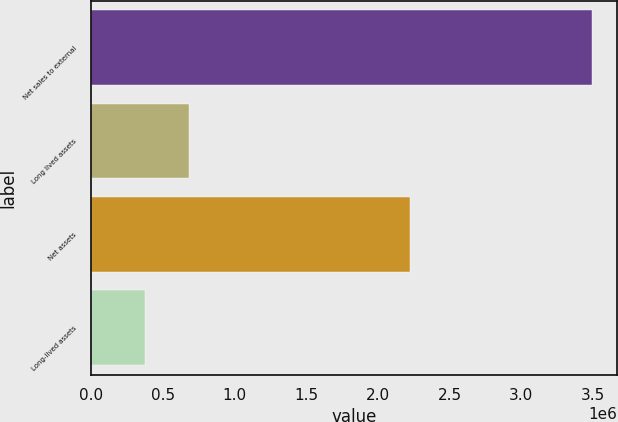Convert chart to OTSL. <chart><loc_0><loc_0><loc_500><loc_500><bar_chart><fcel>Net sales to external<fcel>Long lived assets<fcel>Net assets<fcel>Long-lived assets<nl><fcel>3.49408e+06<fcel>686140<fcel>2.22585e+06<fcel>374147<nl></chart> 